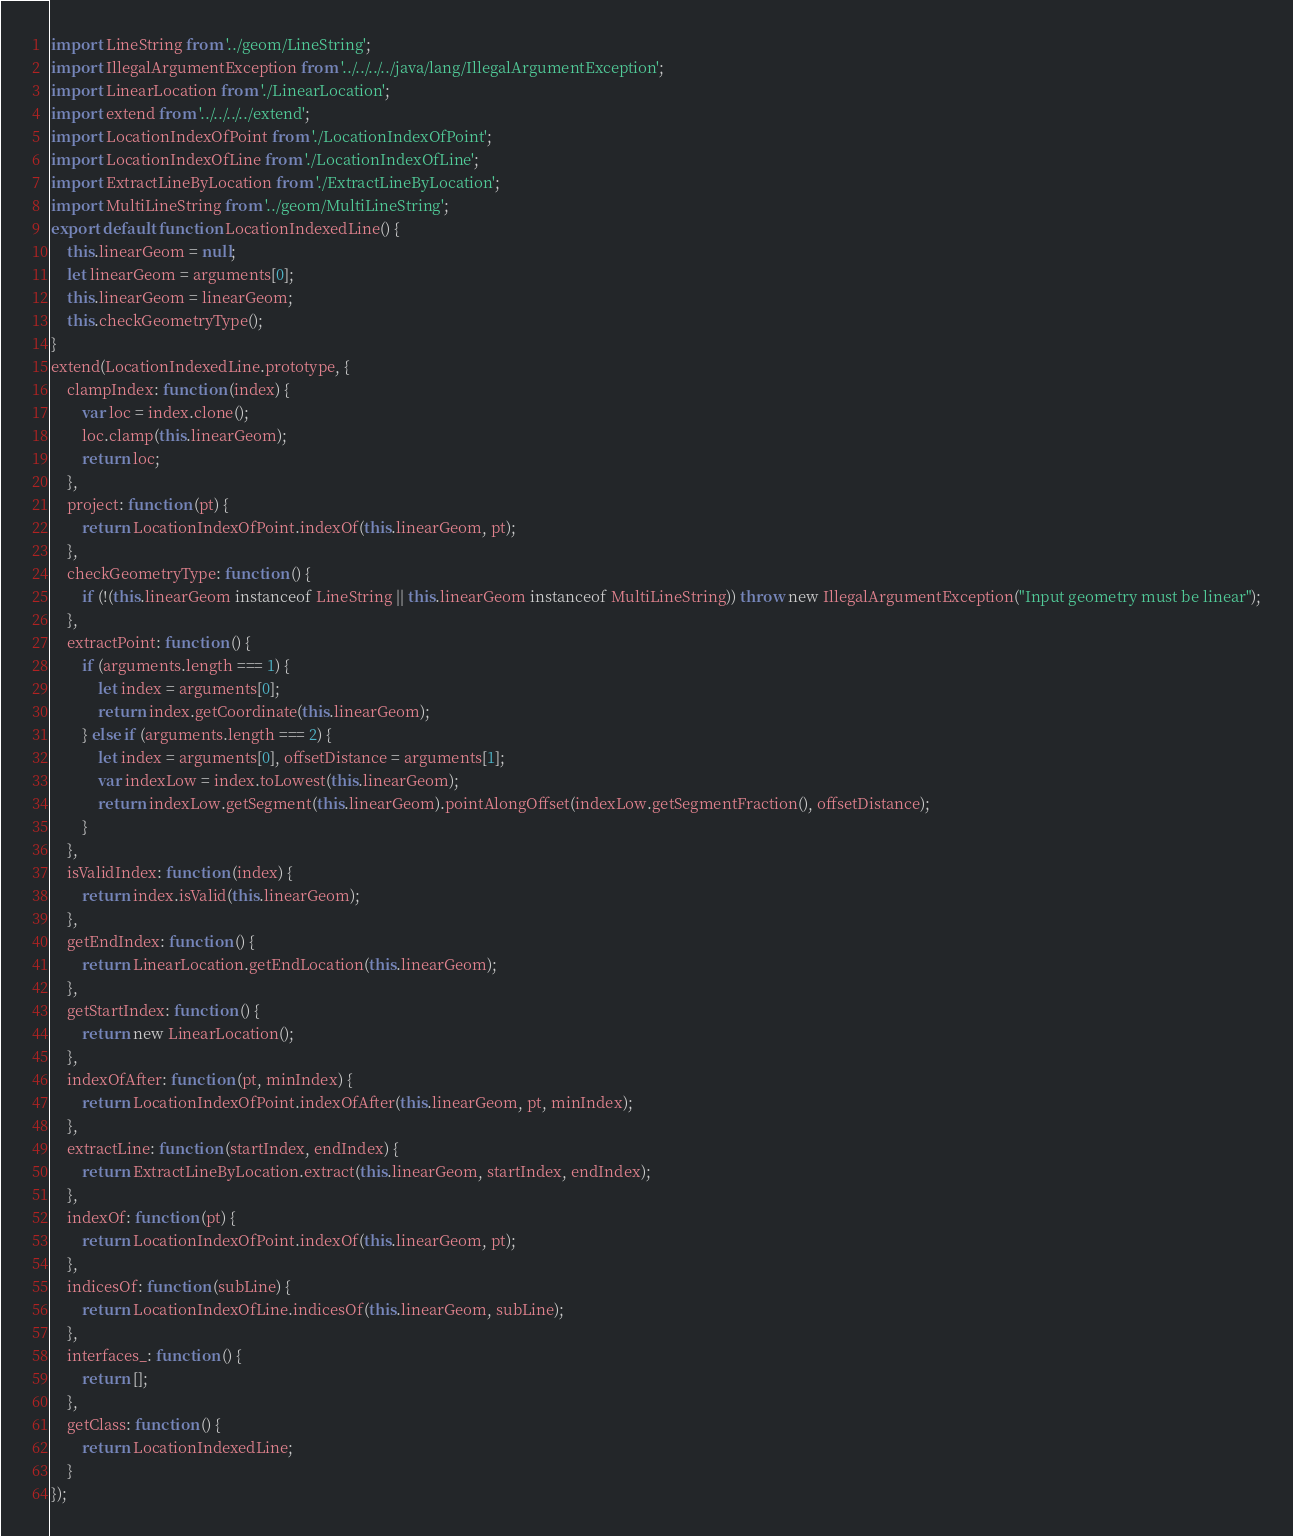Convert code to text. <code><loc_0><loc_0><loc_500><loc_500><_JavaScript_>import LineString from '../geom/LineString';
import IllegalArgumentException from '../../../../java/lang/IllegalArgumentException';
import LinearLocation from './LinearLocation';
import extend from '../../../../extend';
import LocationIndexOfPoint from './LocationIndexOfPoint';
import LocationIndexOfLine from './LocationIndexOfLine';
import ExtractLineByLocation from './ExtractLineByLocation';
import MultiLineString from '../geom/MultiLineString';
export default function LocationIndexedLine() {
	this.linearGeom = null;
	let linearGeom = arguments[0];
	this.linearGeom = linearGeom;
	this.checkGeometryType();
}
extend(LocationIndexedLine.prototype, {
	clampIndex: function (index) {
		var loc = index.clone();
		loc.clamp(this.linearGeom);
		return loc;
	},
	project: function (pt) {
		return LocationIndexOfPoint.indexOf(this.linearGeom, pt);
	},
	checkGeometryType: function () {
		if (!(this.linearGeom instanceof LineString || this.linearGeom instanceof MultiLineString)) throw new IllegalArgumentException("Input geometry must be linear");
	},
	extractPoint: function () {
		if (arguments.length === 1) {
			let index = arguments[0];
			return index.getCoordinate(this.linearGeom);
		} else if (arguments.length === 2) {
			let index = arguments[0], offsetDistance = arguments[1];
			var indexLow = index.toLowest(this.linearGeom);
			return indexLow.getSegment(this.linearGeom).pointAlongOffset(indexLow.getSegmentFraction(), offsetDistance);
		}
	},
	isValidIndex: function (index) {
		return index.isValid(this.linearGeom);
	},
	getEndIndex: function () {
		return LinearLocation.getEndLocation(this.linearGeom);
	},
	getStartIndex: function () {
		return new LinearLocation();
	},
	indexOfAfter: function (pt, minIndex) {
		return LocationIndexOfPoint.indexOfAfter(this.linearGeom, pt, minIndex);
	},
	extractLine: function (startIndex, endIndex) {
		return ExtractLineByLocation.extract(this.linearGeom, startIndex, endIndex);
	},
	indexOf: function (pt) {
		return LocationIndexOfPoint.indexOf(this.linearGeom, pt);
	},
	indicesOf: function (subLine) {
		return LocationIndexOfLine.indicesOf(this.linearGeom, subLine);
	},
	interfaces_: function () {
		return [];
	},
	getClass: function () {
		return LocationIndexedLine;
	}
});
</code> 